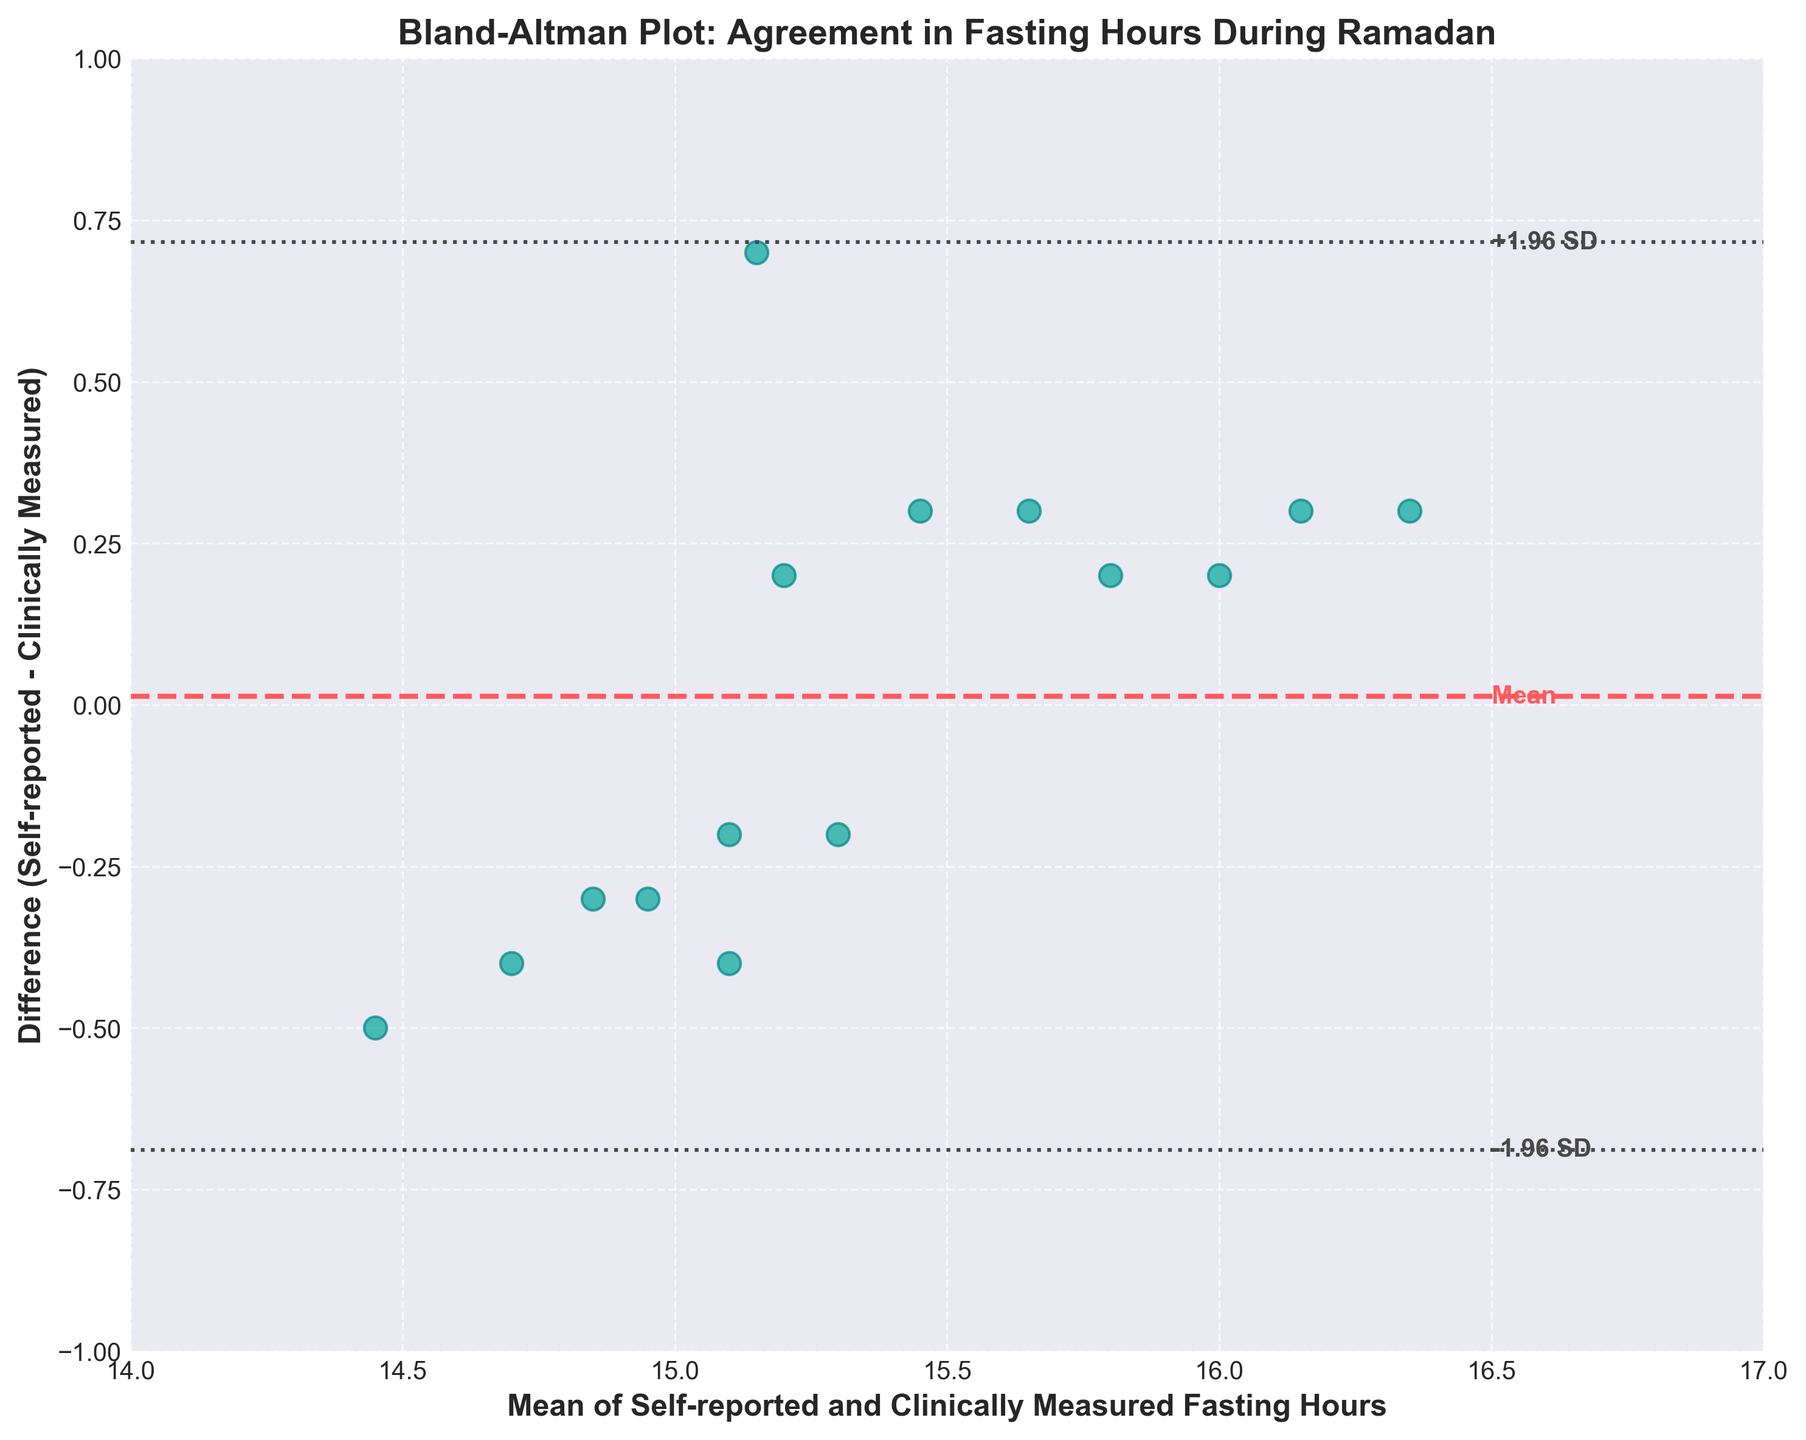How many data points are represented in the plot? Count the number of dots (data points) in the scatter plot.
Answer: 15 What is the title of the plot? Look for the text at the top of the plot that summarizes what the plot is about.
Answer: Bland-Altman Plot: Agreement in Fasting Hours During Ramadan What does the horizontal dashed line represent? Identify the dashed line and check the labels or legend (if available) to understand its meaning.
Answer: Mean What are the values for the limits of agreement? Look for the dashed and dotted lines indicating the limits and their numerical labels.
Answer: Approximately -0.61 and 0.92 What is the average difference between self-reported and clinically measured fasting hours? This difference is marked by the dashed line, which represents the mean difference on the plot.
Answer: Approximately 0.16 Is there any data point where the self-reported fasting hours are equal to the clinically measured hours? Check if any data points fall on the x-axis where the difference (y-value) is zero.
Answer: No What does a negative difference indicate in this plot? Analyze what it means when a data point is below the x-axis (negative y-value).
Answer: Self-reported fasting hours are less than clinically measured fasting hours Which participant has the highest positive difference between self-reported and clinically measured fasting hours? Identify the participant's data point with the highest y-value above the x-axis.
Answer: Ahmet Yilmaz What are the mean and clinically measured fasting hours for the participant with the largest difference? Locate the data point with the largest difference and determine the mean value and clinically measured fasting hours.
Answer: Ahmet Yilmaz: Mean ~15.15, Clinically measured ~14.8 Are the majority of the differences positive or negative? Count the number of data points above and below the x-axis to see the trend.
Answer: Positive 